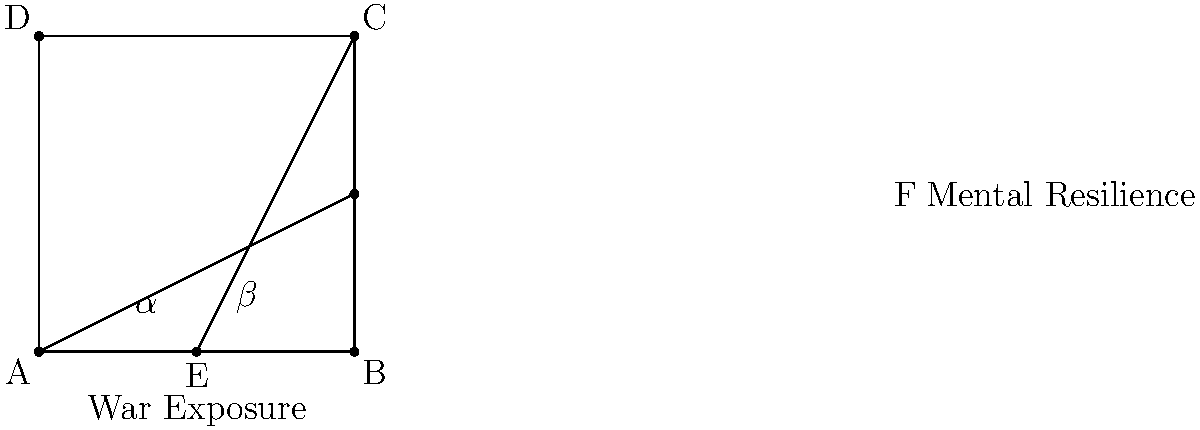In the diagram representing the relationship between war exposure and mental resilience, angles $\alpha$ and $\beta$ form a pair of supplementary angles. If $\alpha = 65°$, what is the measure of $\beta$? To solve this problem, let's follow these steps:

1. Recall that supplementary angles are two angles that add up to 180°.

2. The given information states that angles $\alpha$ and $\beta$ are supplementary.

3. We're also told that $\alpha = 65°$.

4. To find $\beta$, we can use the equation:
   $\alpha + \beta = 180°$

5. Substituting the known value of $\alpha$:
   $65° + \beta = 180°$

6. To solve for $\beta$, subtract 65° from both sides:
   $\beta = 180° - 65°$

7. Perform the subtraction:
   $\beta = 115°$

Therefore, the measure of angle $\beta$ is 115°.
Answer: 115° 